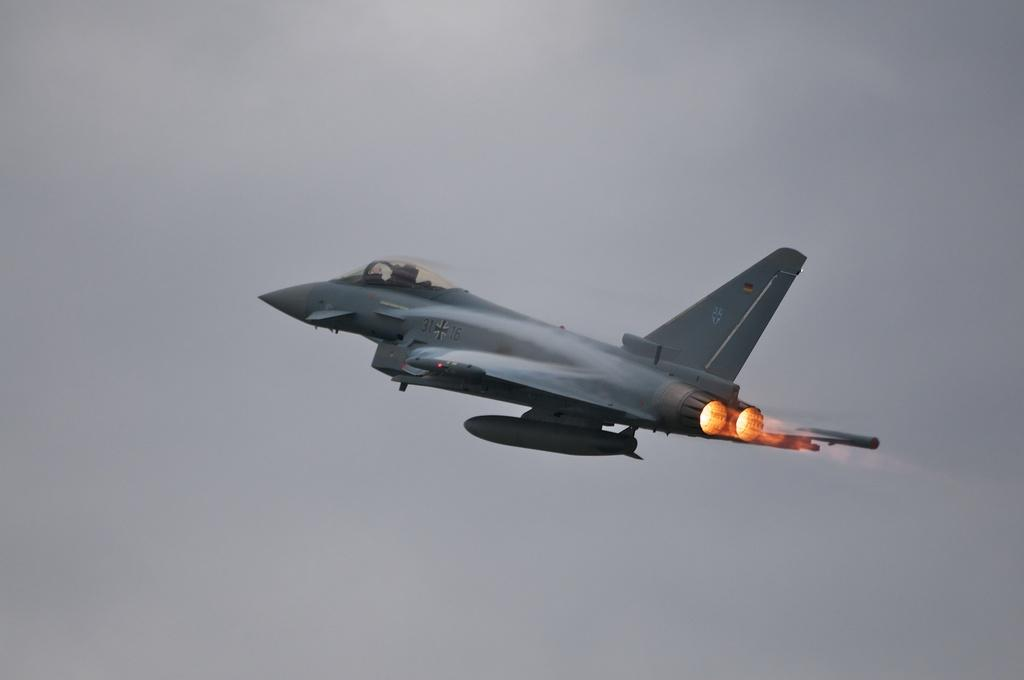What is the main subject of the image? There is a plane in the image. What can be seen in the background of the image? There is a sky in the background of the image. What is happening in the image? There is a fire in the image. How many clovers can be seen growing near the fire in the image? There are no clovers present in the image. What type of weather can be observed in the image? The provided facts do not mention any weather conditions in the image. 